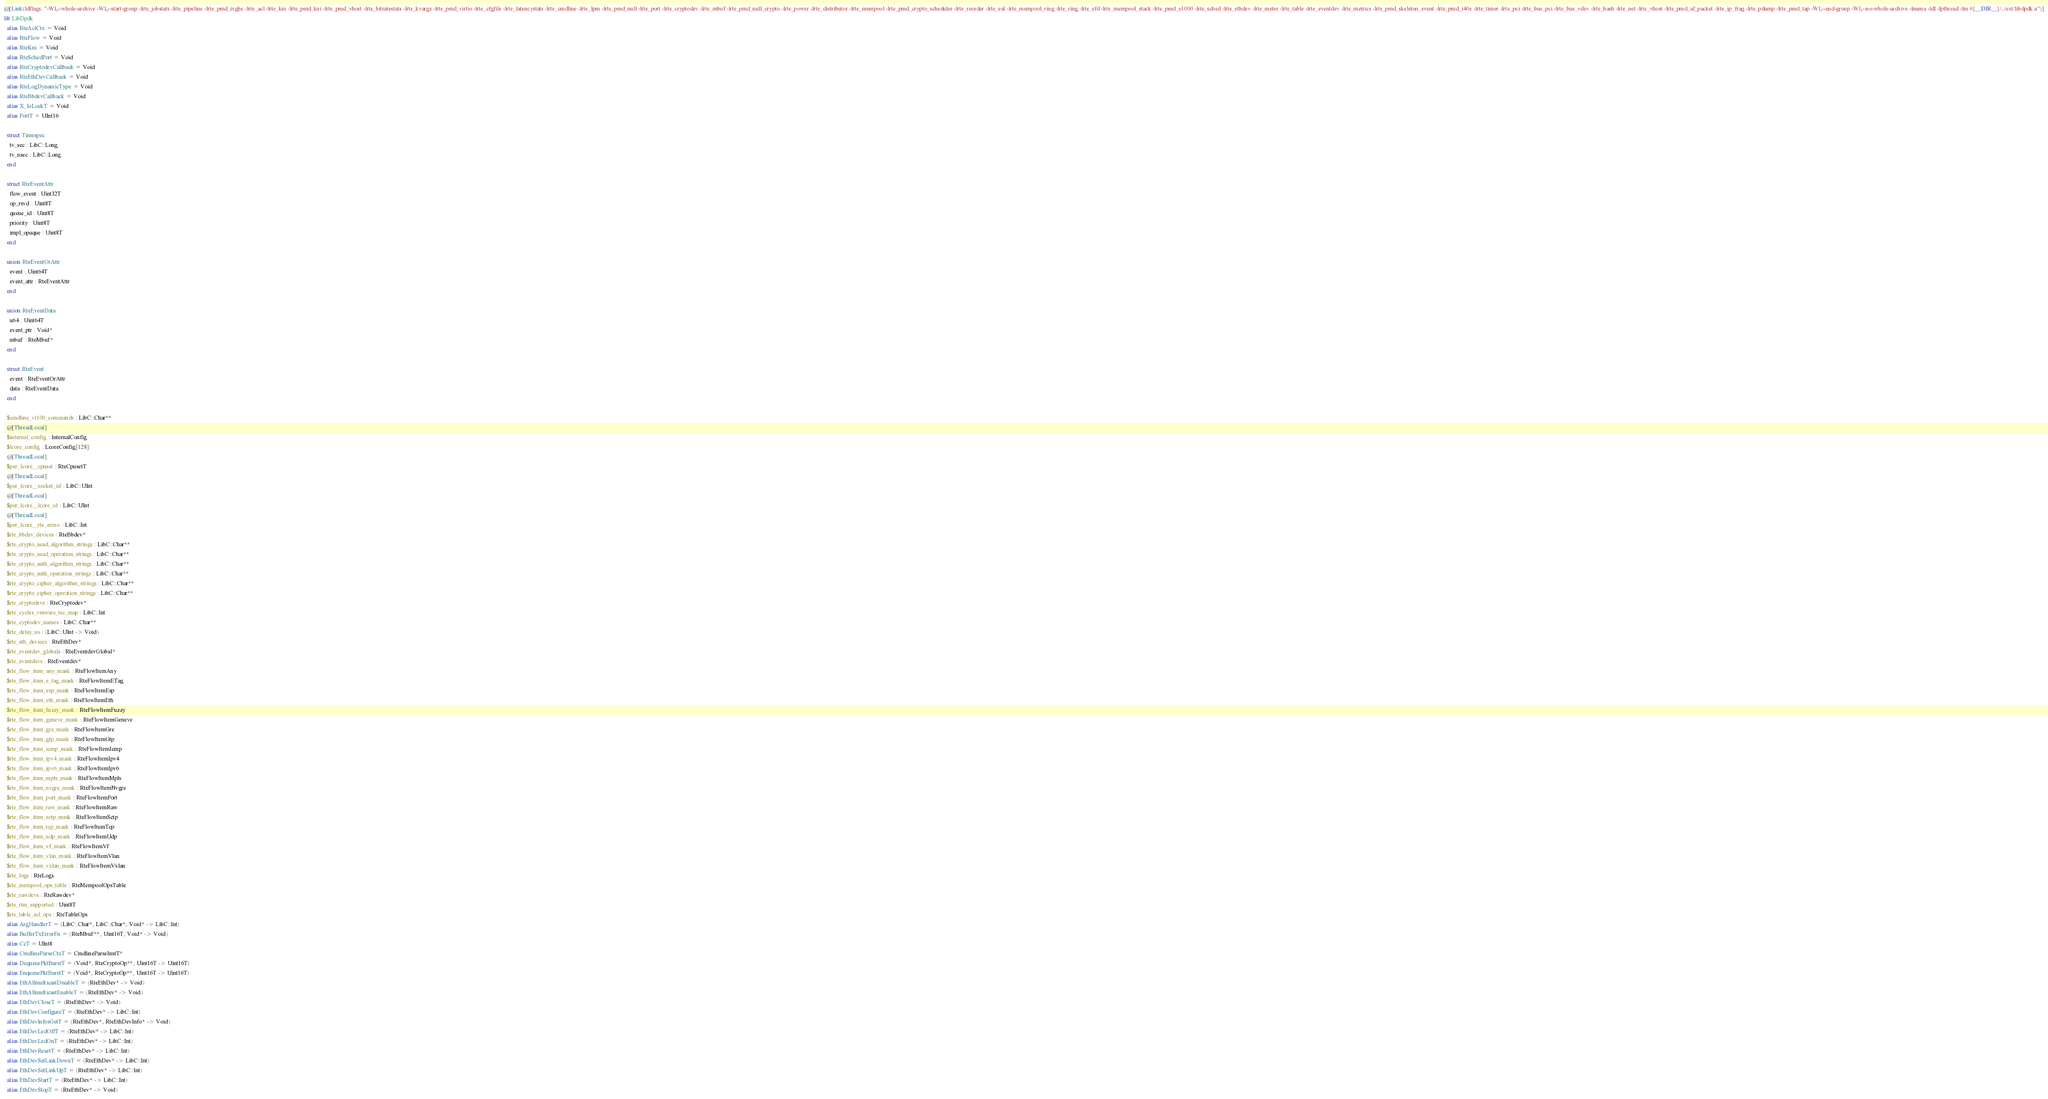<code> <loc_0><loc_0><loc_500><loc_500><_Crystal_>@[Link(ldflags: "-Wl,--whole-archive -Wl,--start-group -lrte_jobstats -lrte_pipeline -lrte_pmd_ixgbe -lrte_acl -lrte_kni -lrte_pmd_kni -lrte_pmd_vhost -lrte_bitratestats -lrte_kvargs -lrte_pmd_virtio -lrte_cfgfile -lrte_latencystats -lrte_cmdline -lrte_lpm -lrte_pmd_null -lrte_port -lrte_cryptodev -lrte_mbuf -lrte_pmd_null_crypto -lrte_power -lrte_distributor -lrte_mempool -lrte_pmd_crypto_scheduler -lrte_reorder -lrte_eal -lrte_mempool_ring -lrte_ring -lrte_efd -lrte_mempool_stack -lrte_pmd_e1000 -lrte_sched -lrte_ethdev -lrte_meter -lrte_table -lrte_eventdev -lrte_metrics -lrte_pmd_skeleton_event -lrte_pmd_i40e -lrte_timer -lrte_pci -lrte_bus_pci -lrte_bus_vdev -lrte_hash -lrte_net -lrte_vhost -lrte_pmd_af_packet -lrte_ip_frag -lrte_pdump -lrte_pmd_tap -Wl,--end-group -Wl,--no-whole-archive -lnuma -ldl -lpthread -lm #{__DIR__}/../ext/libdpdk.a")]
lib LibDpdk
  alias RteAclCtx = Void
  alias RteFlow = Void
  alias RteKni = Void
  alias RteSchedPort = Void
  alias RteCryptodevCallback = Void
  alias RteEthDevCallback = Void
  alias RteLogDynamicType = Void
  alias RteBbdevCallback = Void
  alias X_IoLockT = Void
  alias PortT = UInt16

  struct Timespec
    tv_sec : LibC::Long
    tv_nsec : LibC::Long
  end

  struct RteEventAttr
    flow_event : Uint32T
    op_rsvd : Uint8T
    queue_id : Uint8T
    priority : Uint8T
    impl_opaque : Uint8T
  end

  union RteEventOrAttr
    event : Uint64T
    event_attr : RteEventAttr
  end

  union RteEventData
    u64 : Uint64T
    event_ptr : Void*
    mbuf : RteMbuf*
  end

  struct RteEvent
    event : RteEventOrAttr
    data : RteEventData
  end

  $cmdline_vt100_commands : LibC::Char**
  @[ThreadLocal]
  $internal_config : InternalConfig
  $lcore_config : LcoreConfig[128]
  @[ThreadLocal]
  $per_lcore__cpuset : RteCpusetT
  @[ThreadLocal]
  $per_lcore__socket_id : LibC::UInt
  @[ThreadLocal]
  $per_lcore__lcore_id : LibC::UInt
  @[ThreadLocal]
  $per_lcore__rte_errno : LibC::Int
  $rte_bbdev_devices : RteBbdev*
  $rte_crypto_aead_algorithm_strings : LibC::Char**
  $rte_crypto_aead_operation_strings : LibC::Char**
  $rte_crypto_auth_algorithm_strings : LibC::Char**
  $rte_crypto_auth_operation_strings : LibC::Char**
  $rte_crypto_cipher_algorithm_strings : LibC::Char**
  $rte_crypto_cipher_operation_strings : LibC::Char**
  $rte_cryptodevs : RteCryptodev*
  $rte_cycles_vmware_tsc_map : LibC::Int
  $rte_cyptodev_names : LibC::Char**
  $rte_delay_us : (LibC::UInt -> Void)
  $rte_eth_devices : RteEthDev*
  $rte_eventdev_globals : RteEventdevGlobal*
  $rte_eventdevs : RteEventdev*
  $rte_flow_item_any_mask : RteFlowItemAny
  $rte_flow_item_e_tag_mask : RteFlowItemETag
  $rte_flow_item_esp_mask : RteFlowItemEsp
  $rte_flow_item_eth_mask : RteFlowItemEth
  $rte_flow_item_fuzzy_mask : RteFlowItemFuzzy
  $rte_flow_item_geneve_mask : RteFlowItemGeneve
  $rte_flow_item_gre_mask : RteFlowItemGre
  $rte_flow_item_gtp_mask : RteFlowItemGtp
  $rte_flow_item_icmp_mask : RteFlowItemIcmp
  $rte_flow_item_ipv4_mask : RteFlowItemIpv4
  $rte_flow_item_ipv6_mask : RteFlowItemIpv6
  $rte_flow_item_mpls_mask : RteFlowItemMpls
  $rte_flow_item_nvgre_mask : RteFlowItemNvgre
  $rte_flow_item_port_mask : RteFlowItemPort
  $rte_flow_item_raw_mask : RteFlowItemRaw
  $rte_flow_item_sctp_mask : RteFlowItemSctp
  $rte_flow_item_tcp_mask : RteFlowItemTcp
  $rte_flow_item_udp_mask : RteFlowItemUdp
  $rte_flow_item_vf_mask : RteFlowItemVf
  $rte_flow_item_vlan_mask : RteFlowItemVlan
  $rte_flow_item_vxlan_mask : RteFlowItemVxlan
  $rte_logs : RteLogs
  $rte_mempool_ops_table : RteMempoolOpsTable
  $rte_rawdevs : RteRawdev*
  $rte_rtm_supported : Uint8T
  $rte_table_acl_ops : RteTableOps
  alias ArgHandlerT = (LibC::Char*, LibC::Char*, Void* -> LibC::Int)
  alias BufferTxErrorFn = (RteMbuf**, Uint16T, Void* -> Void)
  alias CcT = UInt8
  alias CmdlineParseCtxT = CmdlineParseInstT*
  alias DequeuePktBurstT = (Void*, RteCryptoOp**, Uint16T -> Uint16T)
  alias EnqueuePktBurstT = (Void*, RteCryptoOp**, Uint16T -> Uint16T)
  alias EthAllmulticastDisableT = (RteEthDev* -> Void)
  alias EthAllmulticastEnableT = (RteEthDev* -> Void)
  alias EthDevCloseT = (RteEthDev* -> Void)
  alias EthDevConfigureT = (RteEthDev* -> LibC::Int)
  alias EthDevInfosGetT = (RteEthDev*, RteEthDevInfo* -> Void)
  alias EthDevLedOffT = (RteEthDev* -> LibC::Int)
  alias EthDevLedOnT = (RteEthDev* -> LibC::Int)
  alias EthDevResetT = (RteEthDev* -> LibC::Int)
  alias EthDevSetLinkDownT = (RteEthDev* -> LibC::Int)
  alias EthDevSetLinkUpT = (RteEthDev* -> LibC::Int)
  alias EthDevStartT = (RteEthDev* -> LibC::Int)
  alias EthDevStopT = (RteEthDev* -> Void)</code> 